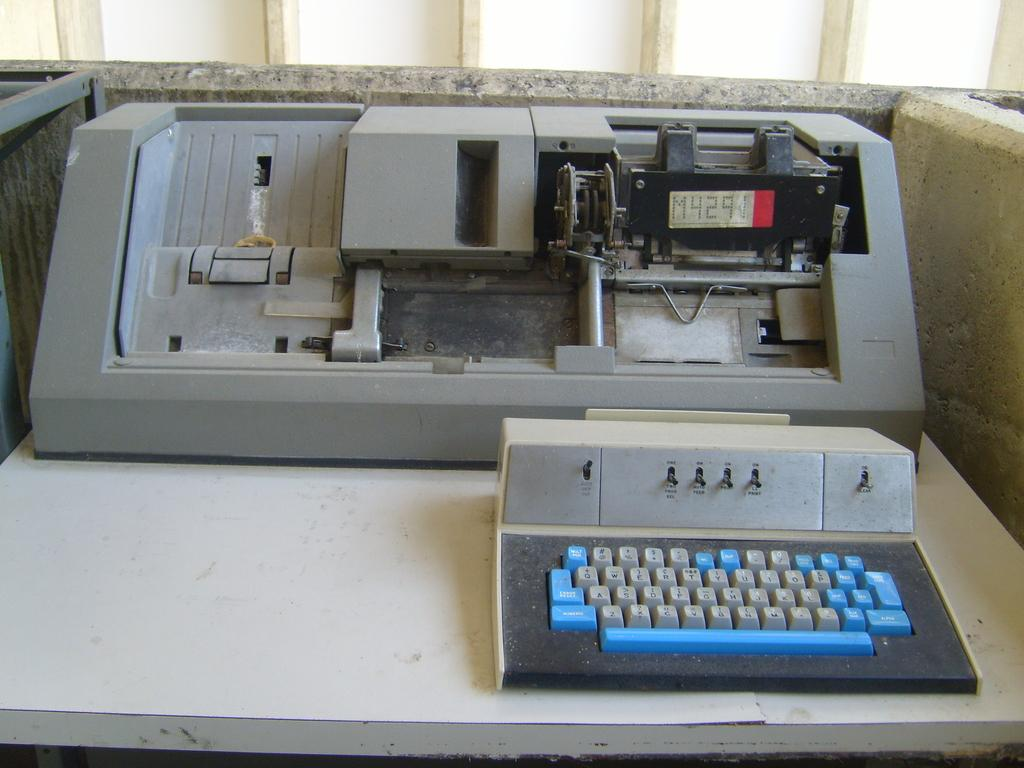What is the main object in the image? There is a machine in the image. What is located near the machine? There is a keyboard in the image. Where are the machine and keyboard placed? Both the machine and keyboard are on a platform. What can be seen in the background of the image? There is a wall visible in the background of the image. What color is the crayon being used to draw on the wall in the image? There is no crayon or drawing on the wall in the image. How does the toothpaste help with the operation of the machine in the image? There is no toothpaste present in the image, and it is not related to the operation of the machine. 